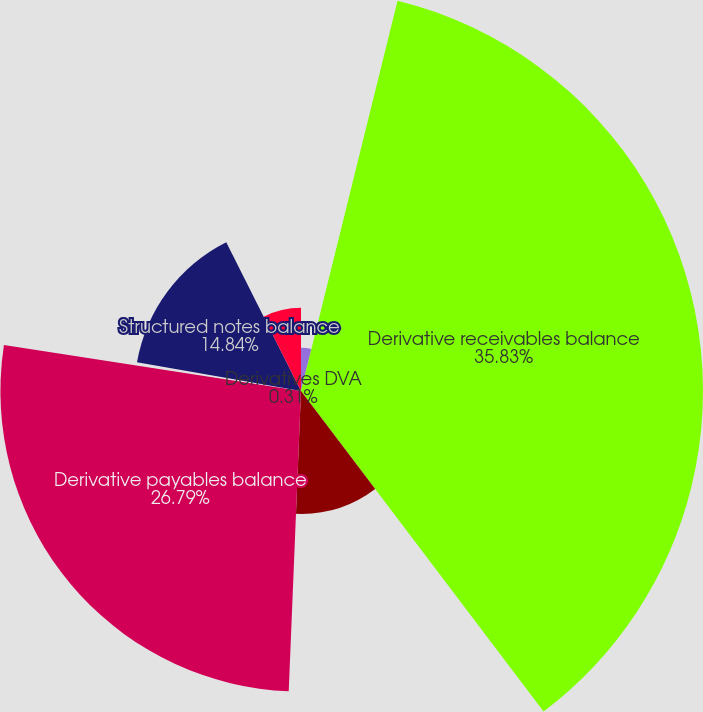Convert chart to OTSL. <chart><loc_0><loc_0><loc_500><loc_500><pie_chart><fcel>December 31 (in millions)<fcel>Derivative receivables balance<fcel>Derivatives CVA (a)<fcel>Derivative payables balance<fcel>Derivatives DVA<fcel>Structured notes balance<fcel>Structured notes DVA<nl><fcel>3.86%<fcel>35.83%<fcel>10.96%<fcel>26.79%<fcel>0.31%<fcel>14.84%<fcel>7.41%<nl></chart> 